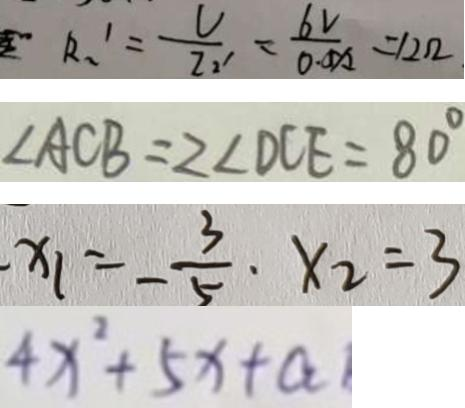<formula> <loc_0><loc_0><loc_500><loc_500>R _ { 2 } ^ { 1 } = \frac { V } { Z _ { 2 } ^ { 1 } } = \frac { 6 v } { 0 . 0 A 2 } = 1 2 \Omega 
 \angle A C B = 2 \angle D C E = 8 0 ^ { \circ } 
 x _ { 1 } = - \frac { 3 } { 5 } \cdot x _ { 2 } = 3 
 4 x ^ { 2 } + 5 x + a</formula> 